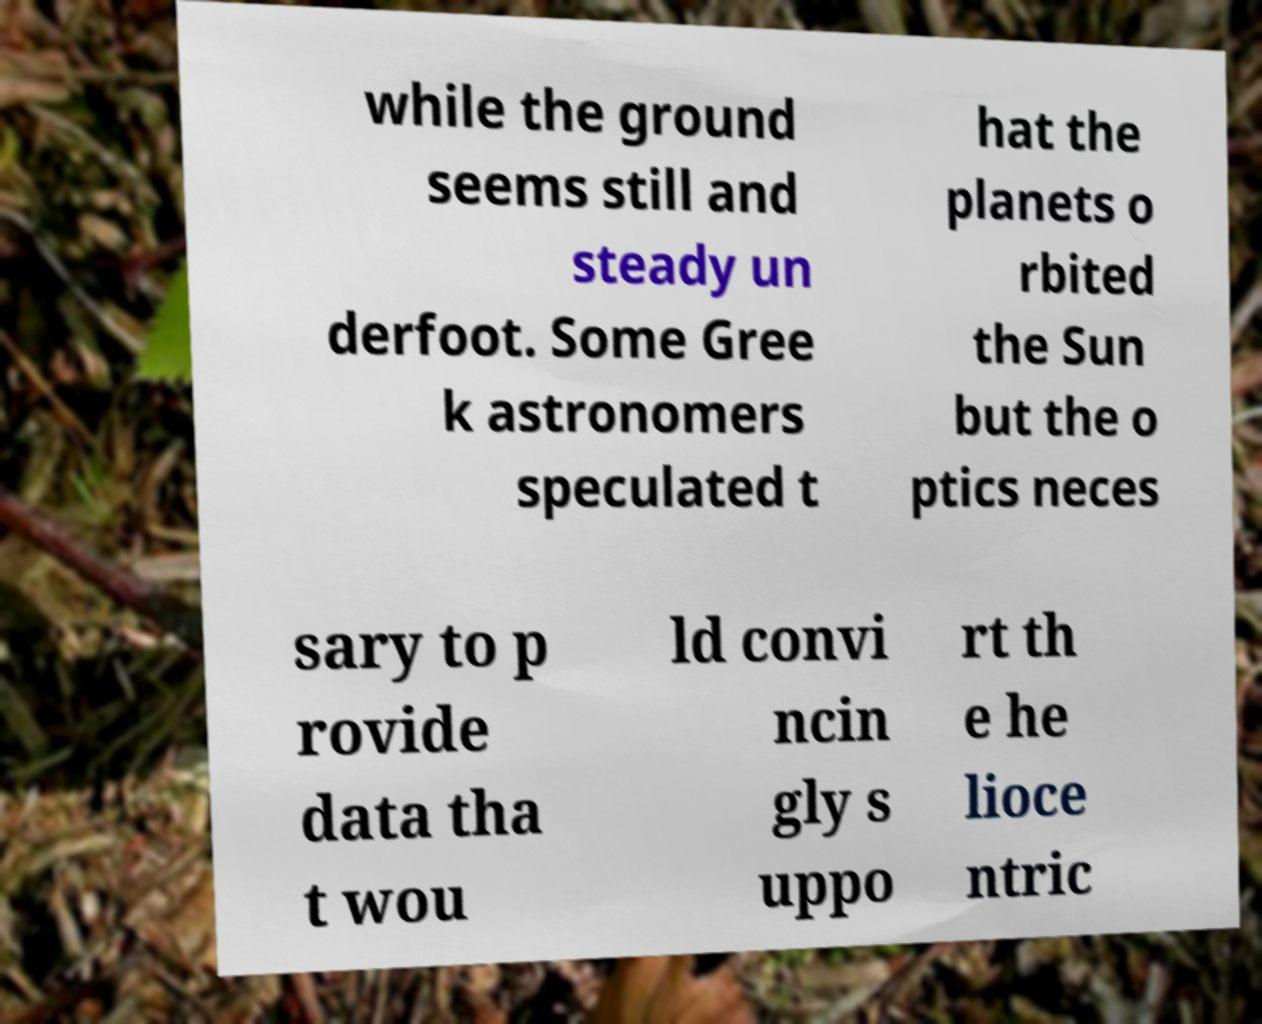Could you assist in decoding the text presented in this image and type it out clearly? while the ground seems still and steady un derfoot. Some Gree k astronomers speculated t hat the planets o rbited the Sun but the o ptics neces sary to p rovide data tha t wou ld convi ncin gly s uppo rt th e he lioce ntric 